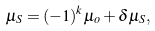<formula> <loc_0><loc_0><loc_500><loc_500>\mu _ { S } = ( - 1 ) ^ { k } \mu _ { o } + \delta \mu _ { S } ,</formula> 